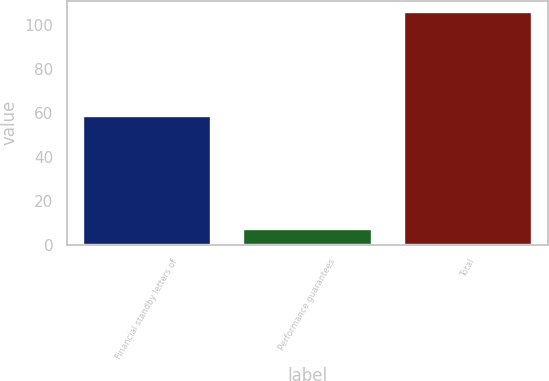Convert chart to OTSL. <chart><loc_0><loc_0><loc_500><loc_500><bar_chart><fcel>Financial standby letters of<fcel>Performance guarantees<fcel>Total<nl><fcel>58.7<fcel>7<fcel>105.9<nl></chart> 